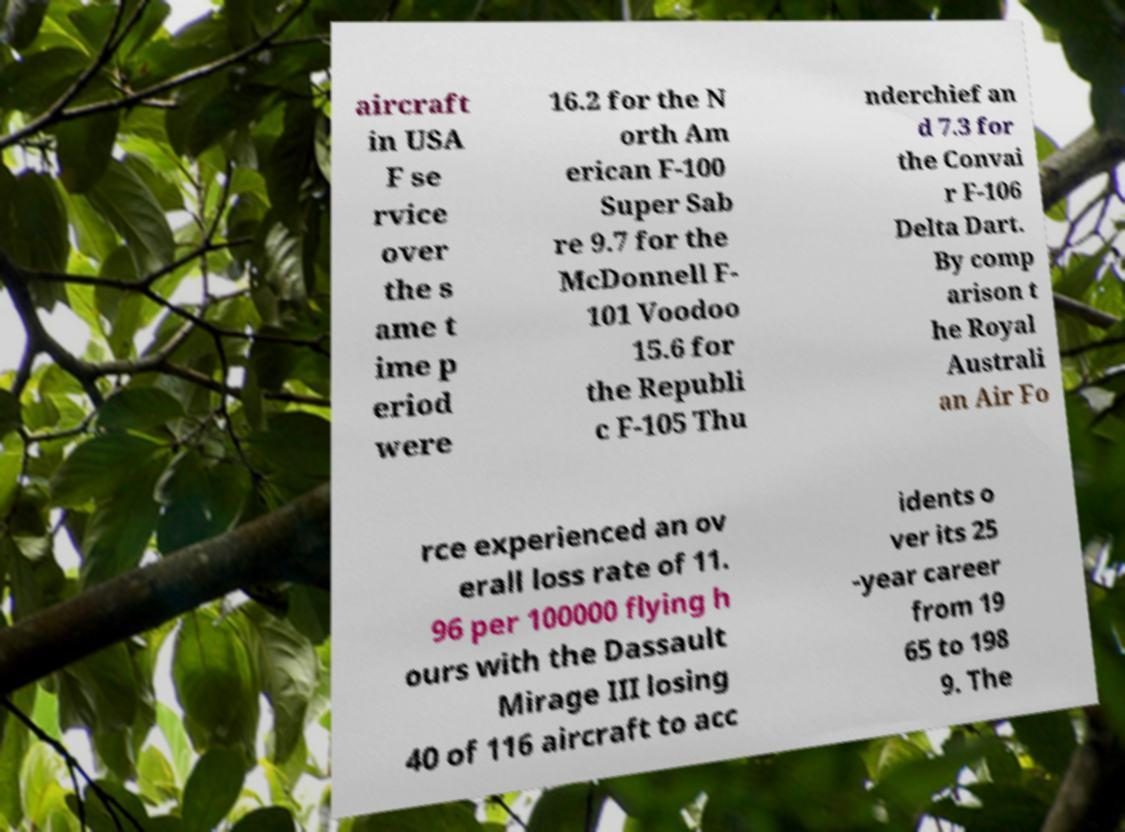What messages or text are displayed in this image? I need them in a readable, typed format. aircraft in USA F se rvice over the s ame t ime p eriod were 16.2 for the N orth Am erican F-100 Super Sab re 9.7 for the McDonnell F- 101 Voodoo 15.6 for the Republi c F-105 Thu nderchief an d 7.3 for the Convai r F-106 Delta Dart. By comp arison t he Royal Australi an Air Fo rce experienced an ov erall loss rate of 11. 96 per 100000 flying h ours with the Dassault Mirage III losing 40 of 116 aircraft to acc idents o ver its 25 -year career from 19 65 to 198 9. The 